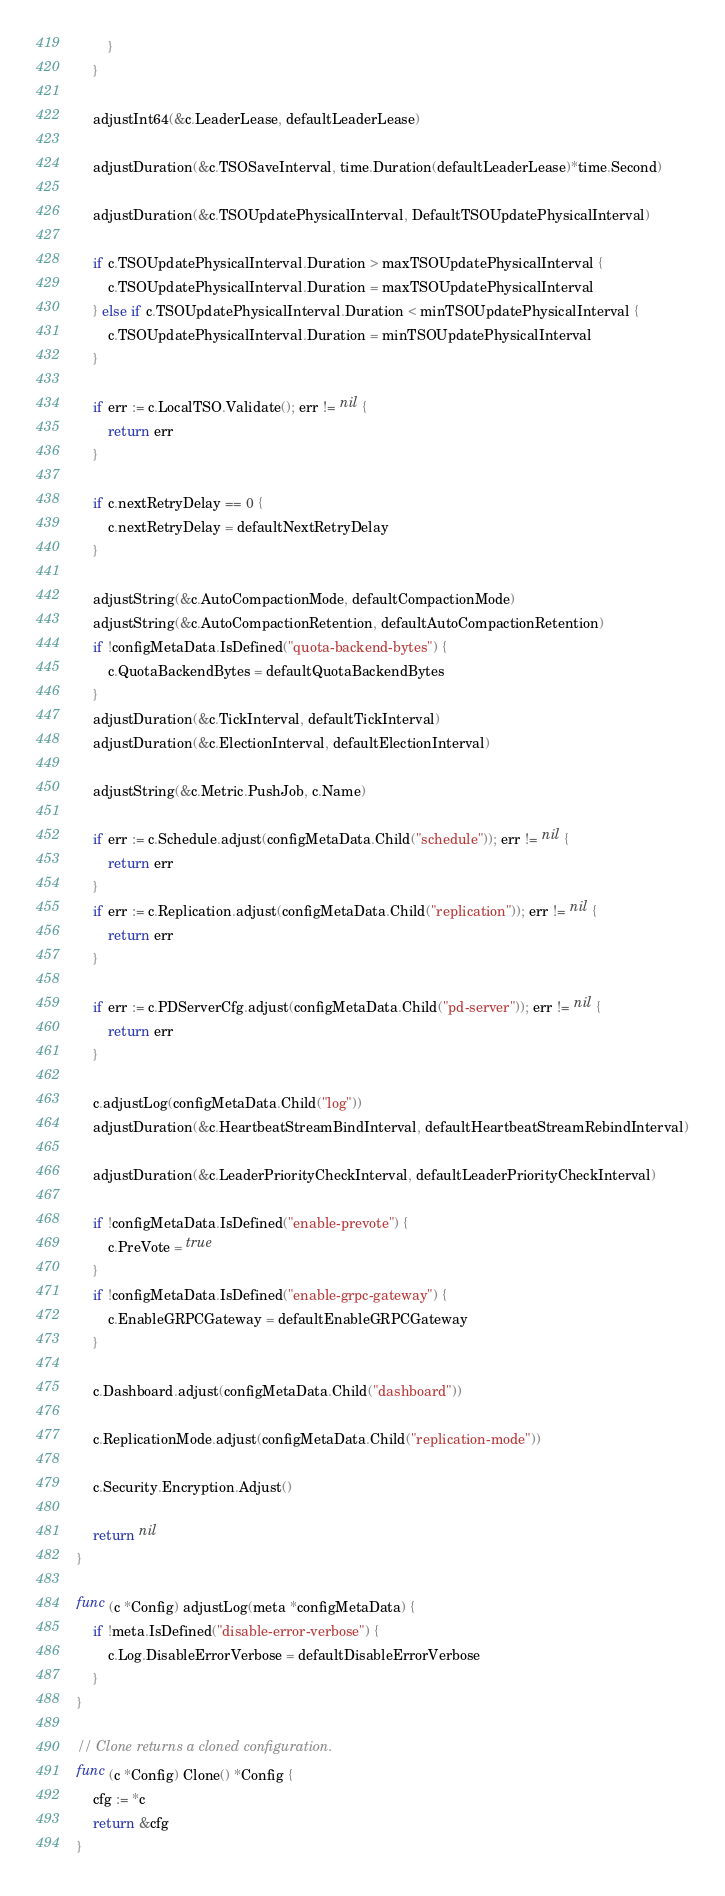Convert code to text. <code><loc_0><loc_0><loc_500><loc_500><_Go_>		}
	}

	adjustInt64(&c.LeaderLease, defaultLeaderLease)

	adjustDuration(&c.TSOSaveInterval, time.Duration(defaultLeaderLease)*time.Second)

	adjustDuration(&c.TSOUpdatePhysicalInterval, DefaultTSOUpdatePhysicalInterval)

	if c.TSOUpdatePhysicalInterval.Duration > maxTSOUpdatePhysicalInterval {
		c.TSOUpdatePhysicalInterval.Duration = maxTSOUpdatePhysicalInterval
	} else if c.TSOUpdatePhysicalInterval.Duration < minTSOUpdatePhysicalInterval {
		c.TSOUpdatePhysicalInterval.Duration = minTSOUpdatePhysicalInterval
	}

	if err := c.LocalTSO.Validate(); err != nil {
		return err
	}

	if c.nextRetryDelay == 0 {
		c.nextRetryDelay = defaultNextRetryDelay
	}

	adjustString(&c.AutoCompactionMode, defaultCompactionMode)
	adjustString(&c.AutoCompactionRetention, defaultAutoCompactionRetention)
	if !configMetaData.IsDefined("quota-backend-bytes") {
		c.QuotaBackendBytes = defaultQuotaBackendBytes
	}
	adjustDuration(&c.TickInterval, defaultTickInterval)
	adjustDuration(&c.ElectionInterval, defaultElectionInterval)

	adjustString(&c.Metric.PushJob, c.Name)

	if err := c.Schedule.adjust(configMetaData.Child("schedule")); err != nil {
		return err
	}
	if err := c.Replication.adjust(configMetaData.Child("replication")); err != nil {
		return err
	}

	if err := c.PDServerCfg.adjust(configMetaData.Child("pd-server")); err != nil {
		return err
	}

	c.adjustLog(configMetaData.Child("log"))
	adjustDuration(&c.HeartbeatStreamBindInterval, defaultHeartbeatStreamRebindInterval)

	adjustDuration(&c.LeaderPriorityCheckInterval, defaultLeaderPriorityCheckInterval)

	if !configMetaData.IsDefined("enable-prevote") {
		c.PreVote = true
	}
	if !configMetaData.IsDefined("enable-grpc-gateway") {
		c.EnableGRPCGateway = defaultEnableGRPCGateway
	}

	c.Dashboard.adjust(configMetaData.Child("dashboard"))

	c.ReplicationMode.adjust(configMetaData.Child("replication-mode"))

	c.Security.Encryption.Adjust()

	return nil
}

func (c *Config) adjustLog(meta *configMetaData) {
	if !meta.IsDefined("disable-error-verbose") {
		c.Log.DisableErrorVerbose = defaultDisableErrorVerbose
	}
}

// Clone returns a cloned configuration.
func (c *Config) Clone() *Config {
	cfg := *c
	return &cfg
}
</code> 